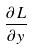<formula> <loc_0><loc_0><loc_500><loc_500>\frac { \partial L } { \partial y }</formula> 